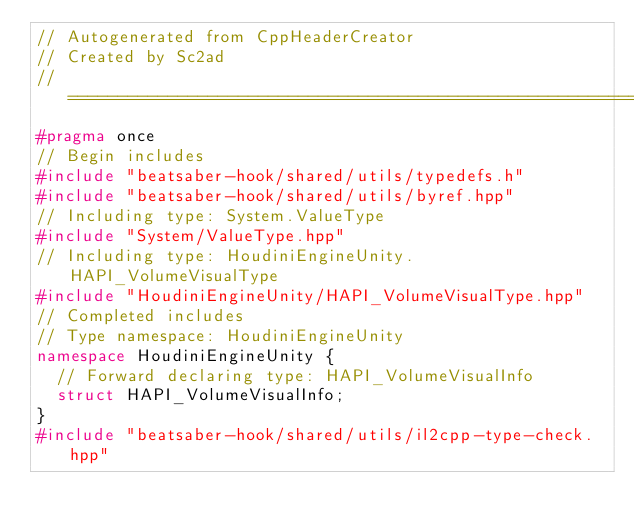Convert code to text. <code><loc_0><loc_0><loc_500><loc_500><_C++_>// Autogenerated from CppHeaderCreator
// Created by Sc2ad
// =========================================================================
#pragma once
// Begin includes
#include "beatsaber-hook/shared/utils/typedefs.h"
#include "beatsaber-hook/shared/utils/byref.hpp"
// Including type: System.ValueType
#include "System/ValueType.hpp"
// Including type: HoudiniEngineUnity.HAPI_VolumeVisualType
#include "HoudiniEngineUnity/HAPI_VolumeVisualType.hpp"
// Completed includes
// Type namespace: HoudiniEngineUnity
namespace HoudiniEngineUnity {
  // Forward declaring type: HAPI_VolumeVisualInfo
  struct HAPI_VolumeVisualInfo;
}
#include "beatsaber-hook/shared/utils/il2cpp-type-check.hpp"</code> 